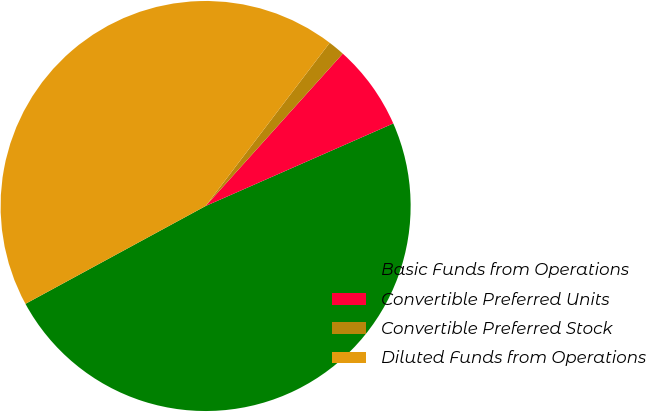Convert chart. <chart><loc_0><loc_0><loc_500><loc_500><pie_chart><fcel>Basic Funds from Operations<fcel>Convertible Preferred Units<fcel>Convertible Preferred Stock<fcel>Diluted Funds from Operations<nl><fcel>48.68%<fcel>6.74%<fcel>1.32%<fcel>43.26%<nl></chart> 